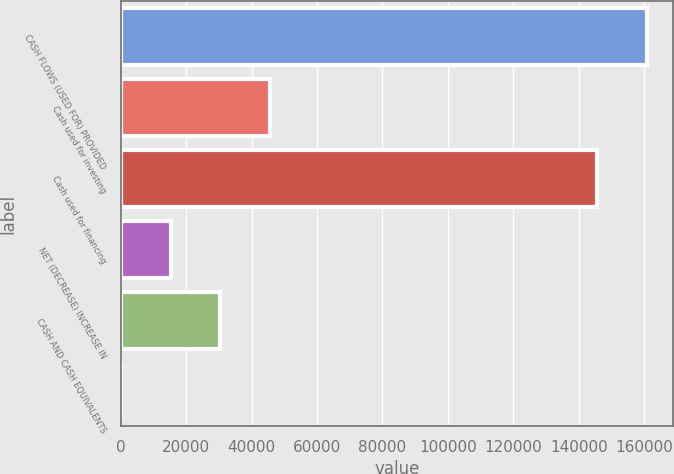<chart> <loc_0><loc_0><loc_500><loc_500><bar_chart><fcel>CASH FLOWS (USED FOR) PROVIDED<fcel>Cash used for investing<fcel>Cash used for financing<fcel>NET (DECREASE) INCREASE IN<fcel>CASH AND CASH EQUIVALENTS<fcel>Unnamed: 5<nl><fcel>160808<fcel>45679.4<fcel>145618<fcel>15299.8<fcel>30489.6<fcel>110<nl></chart> 